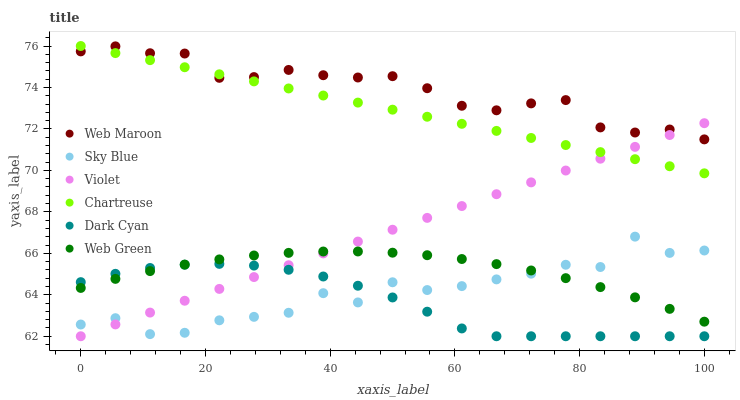Does Dark Cyan have the minimum area under the curve?
Answer yes or no. Yes. Does Web Maroon have the maximum area under the curve?
Answer yes or no. Yes. Does Web Green have the minimum area under the curve?
Answer yes or no. No. Does Web Green have the maximum area under the curve?
Answer yes or no. No. Is Violet the smoothest?
Answer yes or no. Yes. Is Sky Blue the roughest?
Answer yes or no. Yes. Is Web Green the smoothest?
Answer yes or no. No. Is Web Green the roughest?
Answer yes or no. No. Does Violet have the lowest value?
Answer yes or no. Yes. Does Web Green have the lowest value?
Answer yes or no. No. Does Chartreuse have the highest value?
Answer yes or no. Yes. Does Web Green have the highest value?
Answer yes or no. No. Is Sky Blue less than Web Maroon?
Answer yes or no. Yes. Is Web Maroon greater than Dark Cyan?
Answer yes or no. Yes. Does Dark Cyan intersect Sky Blue?
Answer yes or no. Yes. Is Dark Cyan less than Sky Blue?
Answer yes or no. No. Is Dark Cyan greater than Sky Blue?
Answer yes or no. No. Does Sky Blue intersect Web Maroon?
Answer yes or no. No. 